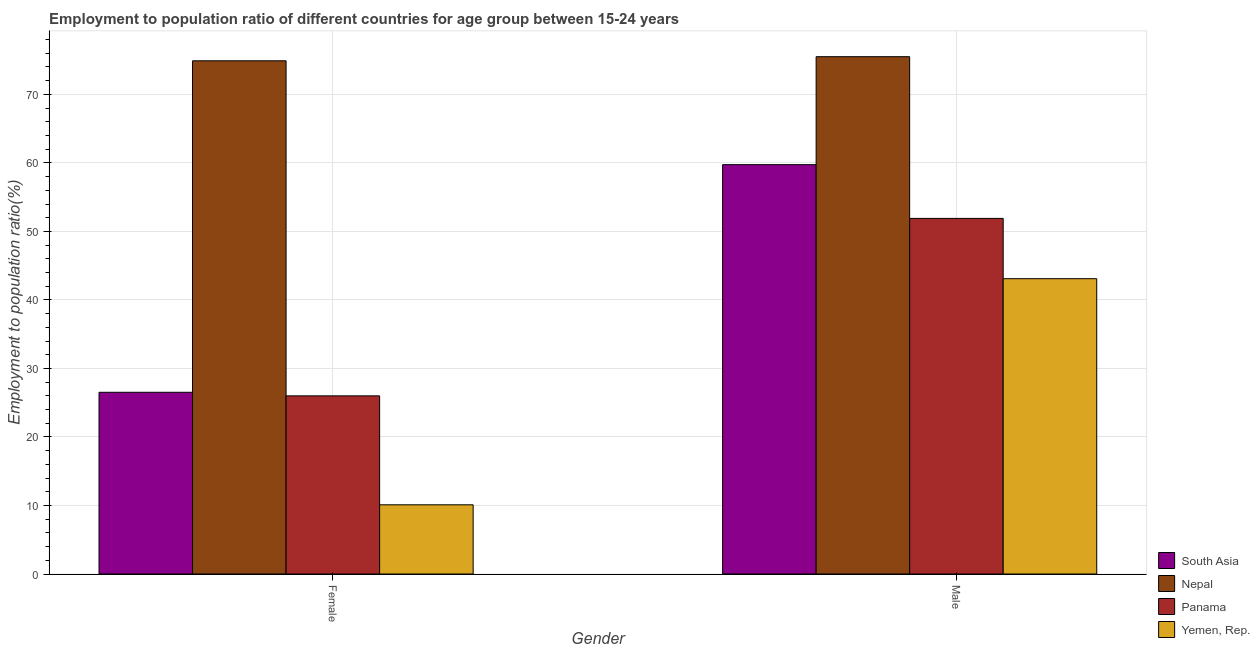How many groups of bars are there?
Make the answer very short. 2. Are the number of bars per tick equal to the number of legend labels?
Give a very brief answer. Yes. Are the number of bars on each tick of the X-axis equal?
Keep it short and to the point. Yes. How many bars are there on the 1st tick from the left?
Your answer should be compact. 4. What is the employment to population ratio(male) in South Asia?
Your answer should be compact. 59.74. Across all countries, what is the maximum employment to population ratio(female)?
Provide a short and direct response. 74.9. Across all countries, what is the minimum employment to population ratio(male)?
Offer a very short reply. 43.1. In which country was the employment to population ratio(female) maximum?
Ensure brevity in your answer.  Nepal. In which country was the employment to population ratio(male) minimum?
Your answer should be very brief. Yemen, Rep. What is the total employment to population ratio(male) in the graph?
Provide a succinct answer. 230.24. What is the difference between the employment to population ratio(female) in Nepal and that in Panama?
Make the answer very short. 48.9. What is the difference between the employment to population ratio(male) in Panama and the employment to population ratio(female) in Yemen, Rep.?
Your response must be concise. 41.8. What is the average employment to population ratio(male) per country?
Give a very brief answer. 57.56. What is the difference between the employment to population ratio(female) and employment to population ratio(male) in South Asia?
Your answer should be very brief. -33.22. What is the ratio of the employment to population ratio(male) in Nepal to that in Yemen, Rep.?
Give a very brief answer. 1.75. In how many countries, is the employment to population ratio(male) greater than the average employment to population ratio(male) taken over all countries?
Make the answer very short. 2. What does the 3rd bar from the left in Female represents?
Your answer should be compact. Panama. Are all the bars in the graph horizontal?
Offer a very short reply. No. What is the difference between two consecutive major ticks on the Y-axis?
Ensure brevity in your answer.  10. Does the graph contain any zero values?
Offer a very short reply. No. Does the graph contain grids?
Ensure brevity in your answer.  Yes. Where does the legend appear in the graph?
Provide a succinct answer. Bottom right. How many legend labels are there?
Your answer should be compact. 4. What is the title of the graph?
Your response must be concise. Employment to population ratio of different countries for age group between 15-24 years. Does "Malta" appear as one of the legend labels in the graph?
Provide a short and direct response. No. What is the label or title of the Y-axis?
Provide a succinct answer. Employment to population ratio(%). What is the Employment to population ratio(%) in South Asia in Female?
Offer a very short reply. 26.52. What is the Employment to population ratio(%) of Nepal in Female?
Your answer should be compact. 74.9. What is the Employment to population ratio(%) in Yemen, Rep. in Female?
Ensure brevity in your answer.  10.1. What is the Employment to population ratio(%) in South Asia in Male?
Your response must be concise. 59.74. What is the Employment to population ratio(%) of Nepal in Male?
Your answer should be compact. 75.5. What is the Employment to population ratio(%) in Panama in Male?
Give a very brief answer. 51.9. What is the Employment to population ratio(%) in Yemen, Rep. in Male?
Your response must be concise. 43.1. Across all Gender, what is the maximum Employment to population ratio(%) of South Asia?
Your answer should be very brief. 59.74. Across all Gender, what is the maximum Employment to population ratio(%) in Nepal?
Ensure brevity in your answer.  75.5. Across all Gender, what is the maximum Employment to population ratio(%) in Panama?
Your response must be concise. 51.9. Across all Gender, what is the maximum Employment to population ratio(%) in Yemen, Rep.?
Make the answer very short. 43.1. Across all Gender, what is the minimum Employment to population ratio(%) of South Asia?
Offer a terse response. 26.52. Across all Gender, what is the minimum Employment to population ratio(%) of Nepal?
Offer a terse response. 74.9. Across all Gender, what is the minimum Employment to population ratio(%) in Yemen, Rep.?
Your response must be concise. 10.1. What is the total Employment to population ratio(%) of South Asia in the graph?
Give a very brief answer. 86.27. What is the total Employment to population ratio(%) in Nepal in the graph?
Provide a short and direct response. 150.4. What is the total Employment to population ratio(%) of Panama in the graph?
Your response must be concise. 77.9. What is the total Employment to population ratio(%) of Yemen, Rep. in the graph?
Provide a succinct answer. 53.2. What is the difference between the Employment to population ratio(%) of South Asia in Female and that in Male?
Provide a succinct answer. -33.22. What is the difference between the Employment to population ratio(%) in Nepal in Female and that in Male?
Give a very brief answer. -0.6. What is the difference between the Employment to population ratio(%) in Panama in Female and that in Male?
Keep it short and to the point. -25.9. What is the difference between the Employment to population ratio(%) in Yemen, Rep. in Female and that in Male?
Your answer should be compact. -33. What is the difference between the Employment to population ratio(%) in South Asia in Female and the Employment to population ratio(%) in Nepal in Male?
Give a very brief answer. -48.98. What is the difference between the Employment to population ratio(%) of South Asia in Female and the Employment to population ratio(%) of Panama in Male?
Your answer should be very brief. -25.38. What is the difference between the Employment to population ratio(%) of South Asia in Female and the Employment to population ratio(%) of Yemen, Rep. in Male?
Ensure brevity in your answer.  -16.58. What is the difference between the Employment to population ratio(%) in Nepal in Female and the Employment to population ratio(%) in Panama in Male?
Offer a terse response. 23. What is the difference between the Employment to population ratio(%) of Nepal in Female and the Employment to population ratio(%) of Yemen, Rep. in Male?
Provide a succinct answer. 31.8. What is the difference between the Employment to population ratio(%) in Panama in Female and the Employment to population ratio(%) in Yemen, Rep. in Male?
Provide a short and direct response. -17.1. What is the average Employment to population ratio(%) in South Asia per Gender?
Offer a terse response. 43.13. What is the average Employment to population ratio(%) of Nepal per Gender?
Provide a succinct answer. 75.2. What is the average Employment to population ratio(%) of Panama per Gender?
Offer a very short reply. 38.95. What is the average Employment to population ratio(%) of Yemen, Rep. per Gender?
Offer a terse response. 26.6. What is the difference between the Employment to population ratio(%) in South Asia and Employment to population ratio(%) in Nepal in Female?
Provide a short and direct response. -48.38. What is the difference between the Employment to population ratio(%) of South Asia and Employment to population ratio(%) of Panama in Female?
Give a very brief answer. 0.52. What is the difference between the Employment to population ratio(%) in South Asia and Employment to population ratio(%) in Yemen, Rep. in Female?
Make the answer very short. 16.42. What is the difference between the Employment to population ratio(%) in Nepal and Employment to population ratio(%) in Panama in Female?
Your response must be concise. 48.9. What is the difference between the Employment to population ratio(%) of Nepal and Employment to population ratio(%) of Yemen, Rep. in Female?
Make the answer very short. 64.8. What is the difference between the Employment to population ratio(%) of Panama and Employment to population ratio(%) of Yemen, Rep. in Female?
Provide a short and direct response. 15.9. What is the difference between the Employment to population ratio(%) of South Asia and Employment to population ratio(%) of Nepal in Male?
Your answer should be compact. -15.76. What is the difference between the Employment to population ratio(%) in South Asia and Employment to population ratio(%) in Panama in Male?
Provide a succinct answer. 7.84. What is the difference between the Employment to population ratio(%) in South Asia and Employment to population ratio(%) in Yemen, Rep. in Male?
Ensure brevity in your answer.  16.64. What is the difference between the Employment to population ratio(%) of Nepal and Employment to population ratio(%) of Panama in Male?
Offer a terse response. 23.6. What is the difference between the Employment to population ratio(%) in Nepal and Employment to population ratio(%) in Yemen, Rep. in Male?
Give a very brief answer. 32.4. What is the ratio of the Employment to population ratio(%) of South Asia in Female to that in Male?
Provide a short and direct response. 0.44. What is the ratio of the Employment to population ratio(%) in Nepal in Female to that in Male?
Give a very brief answer. 0.99. What is the ratio of the Employment to population ratio(%) in Panama in Female to that in Male?
Your answer should be compact. 0.5. What is the ratio of the Employment to population ratio(%) in Yemen, Rep. in Female to that in Male?
Offer a terse response. 0.23. What is the difference between the highest and the second highest Employment to population ratio(%) in South Asia?
Offer a terse response. 33.22. What is the difference between the highest and the second highest Employment to population ratio(%) in Panama?
Provide a succinct answer. 25.9. What is the difference between the highest and the second highest Employment to population ratio(%) in Yemen, Rep.?
Ensure brevity in your answer.  33. What is the difference between the highest and the lowest Employment to population ratio(%) in South Asia?
Ensure brevity in your answer.  33.22. What is the difference between the highest and the lowest Employment to population ratio(%) of Nepal?
Your answer should be compact. 0.6. What is the difference between the highest and the lowest Employment to population ratio(%) of Panama?
Ensure brevity in your answer.  25.9. 